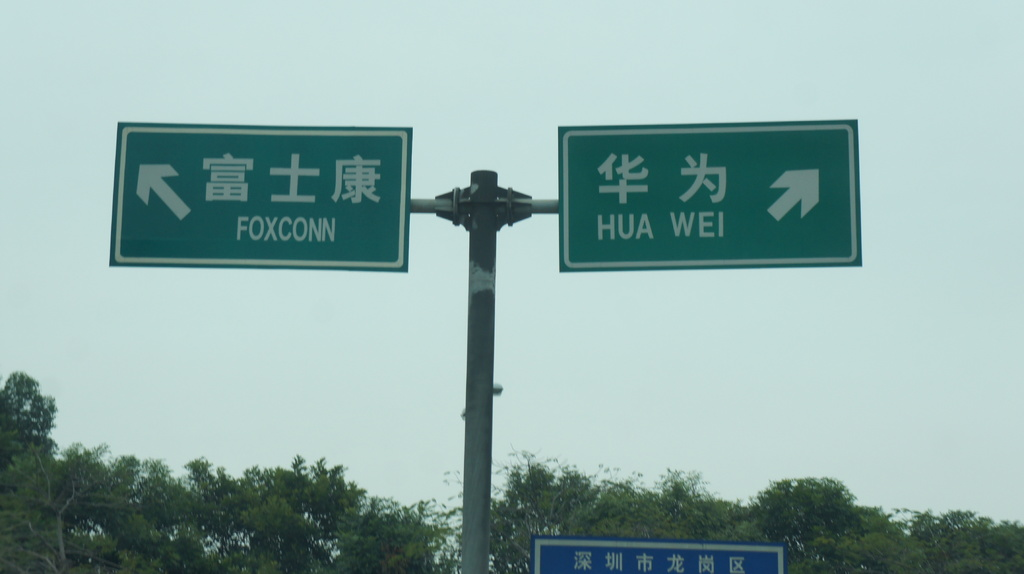Provide a one-sentence caption for the provided image. The road sign directs travelers to turn left for Foxconn and right for Huawei, hinting at significant tech hubs nearby. 